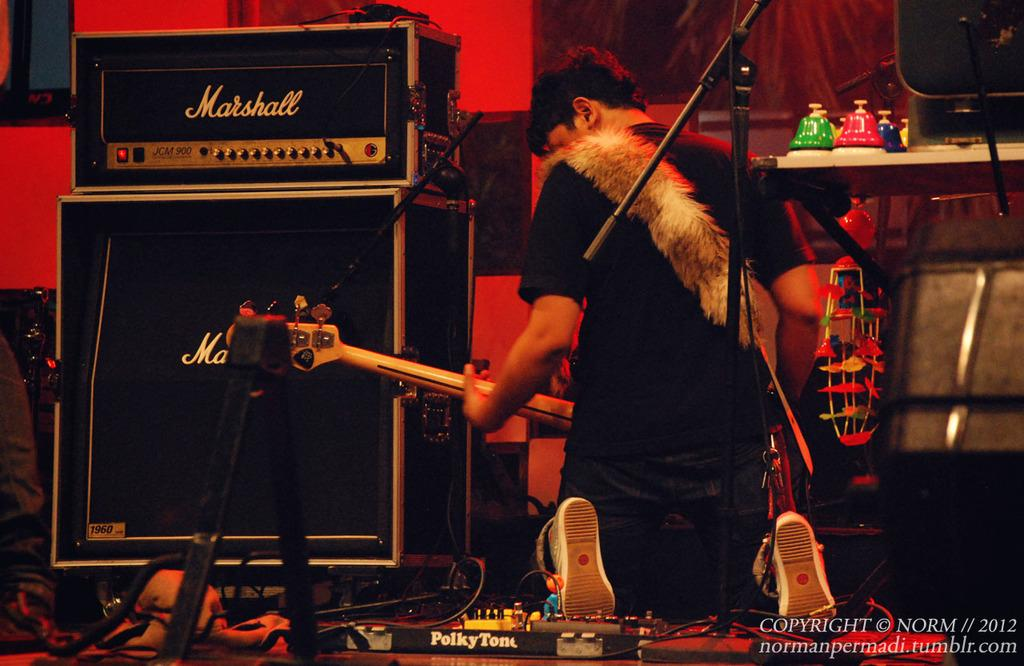What is the person in the image doing? The person is playing a guitar. What is the person wearing? The person is wearing a black shirt. What objects are in front of the person? There are boxes in front of the person. What color is the background of the image? The background color is red. Can you see any fairies flying around the person in the image? No, there are no fairies present in the image. What type of feather is the person using to play the guitar? There is no feather visible in the image; the person is playing the guitar with their hands. 